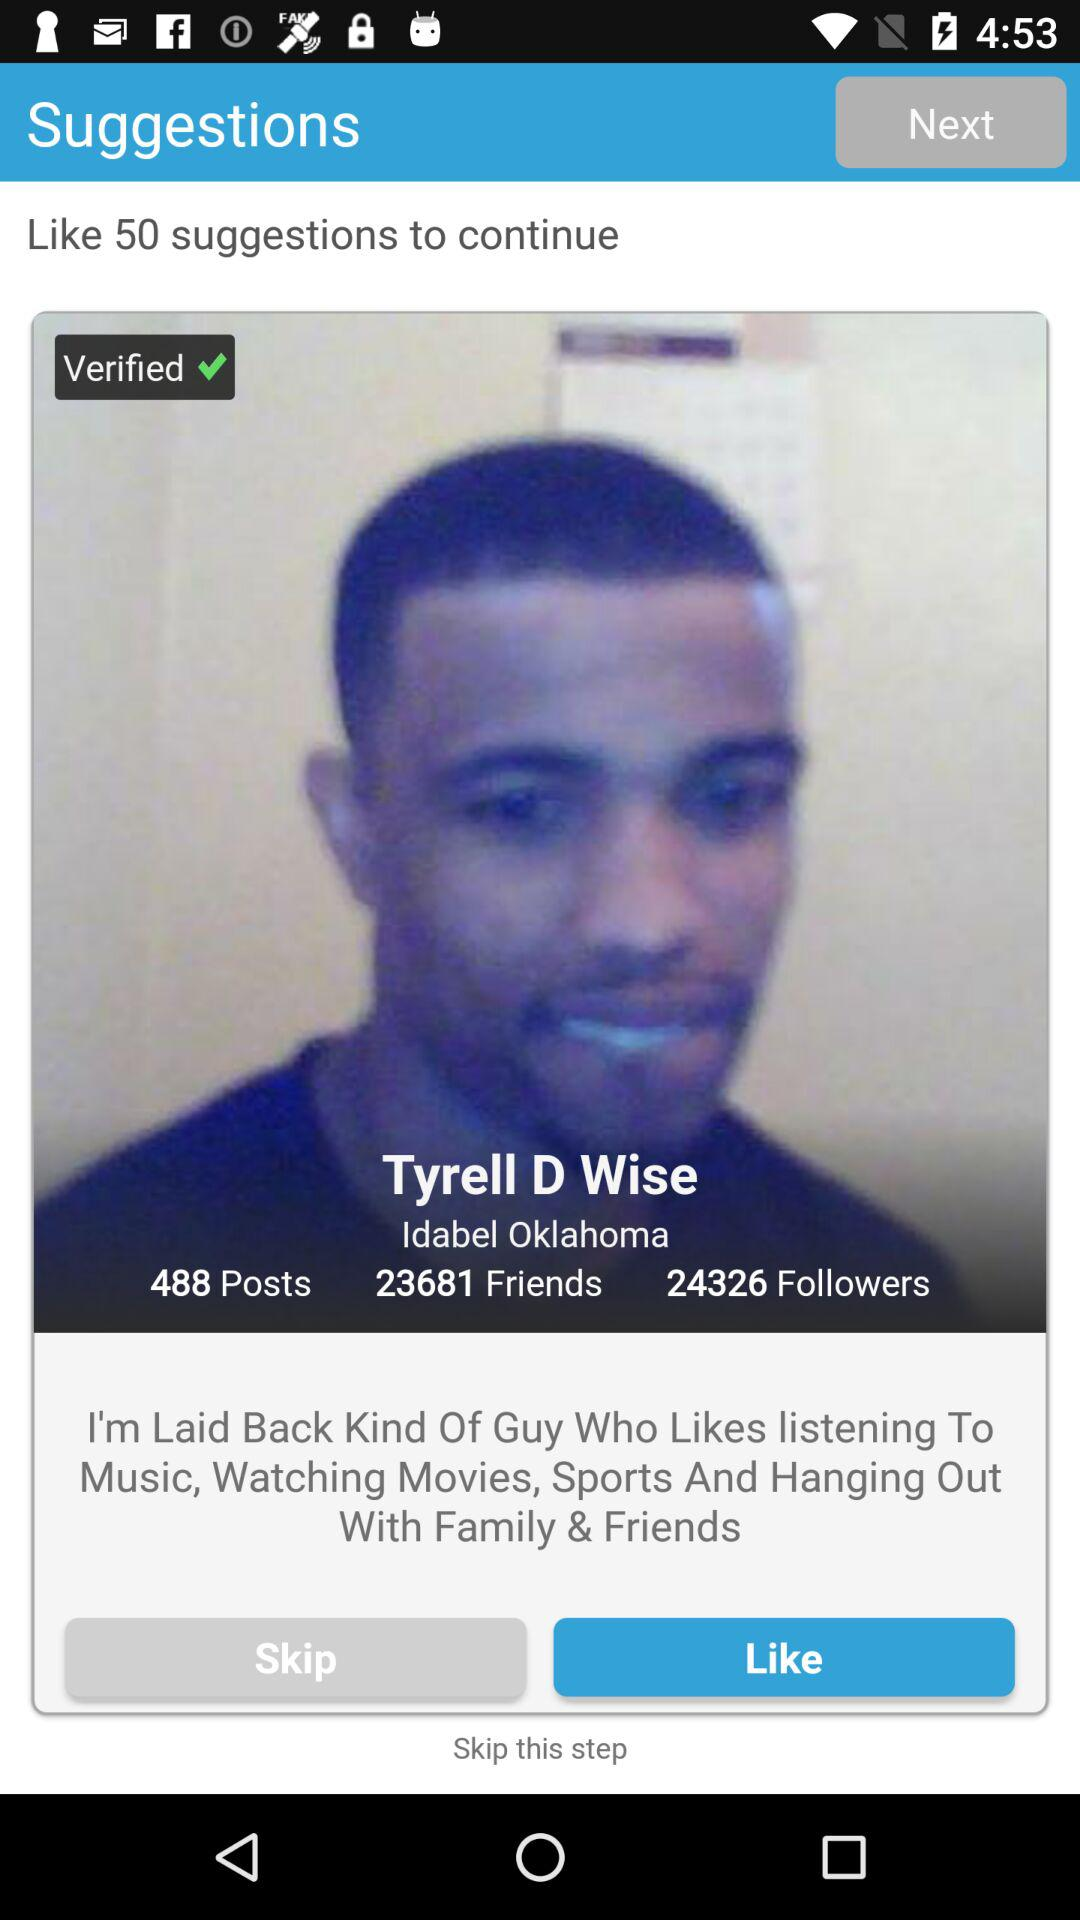What is the number of posts? The number of posts is 488. 